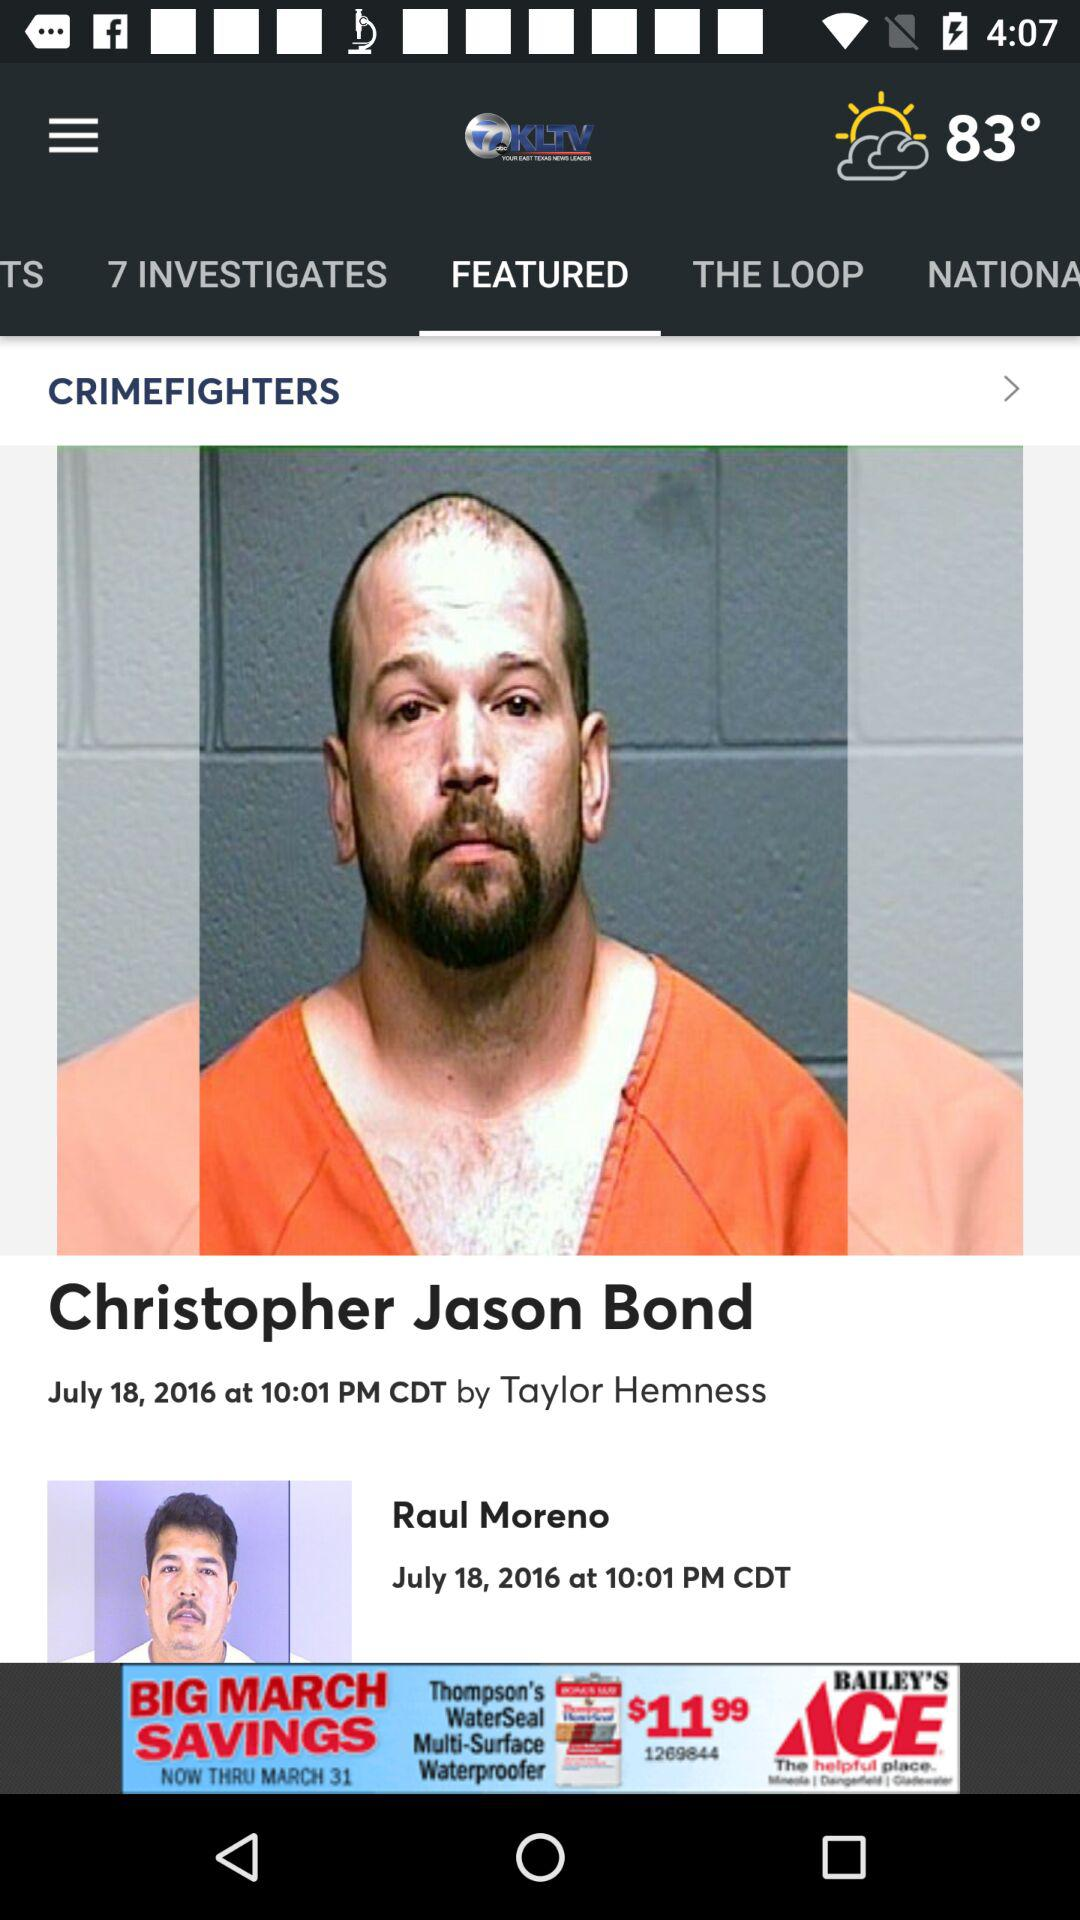Which tab is selected? The selected tab is "FEATURED". 